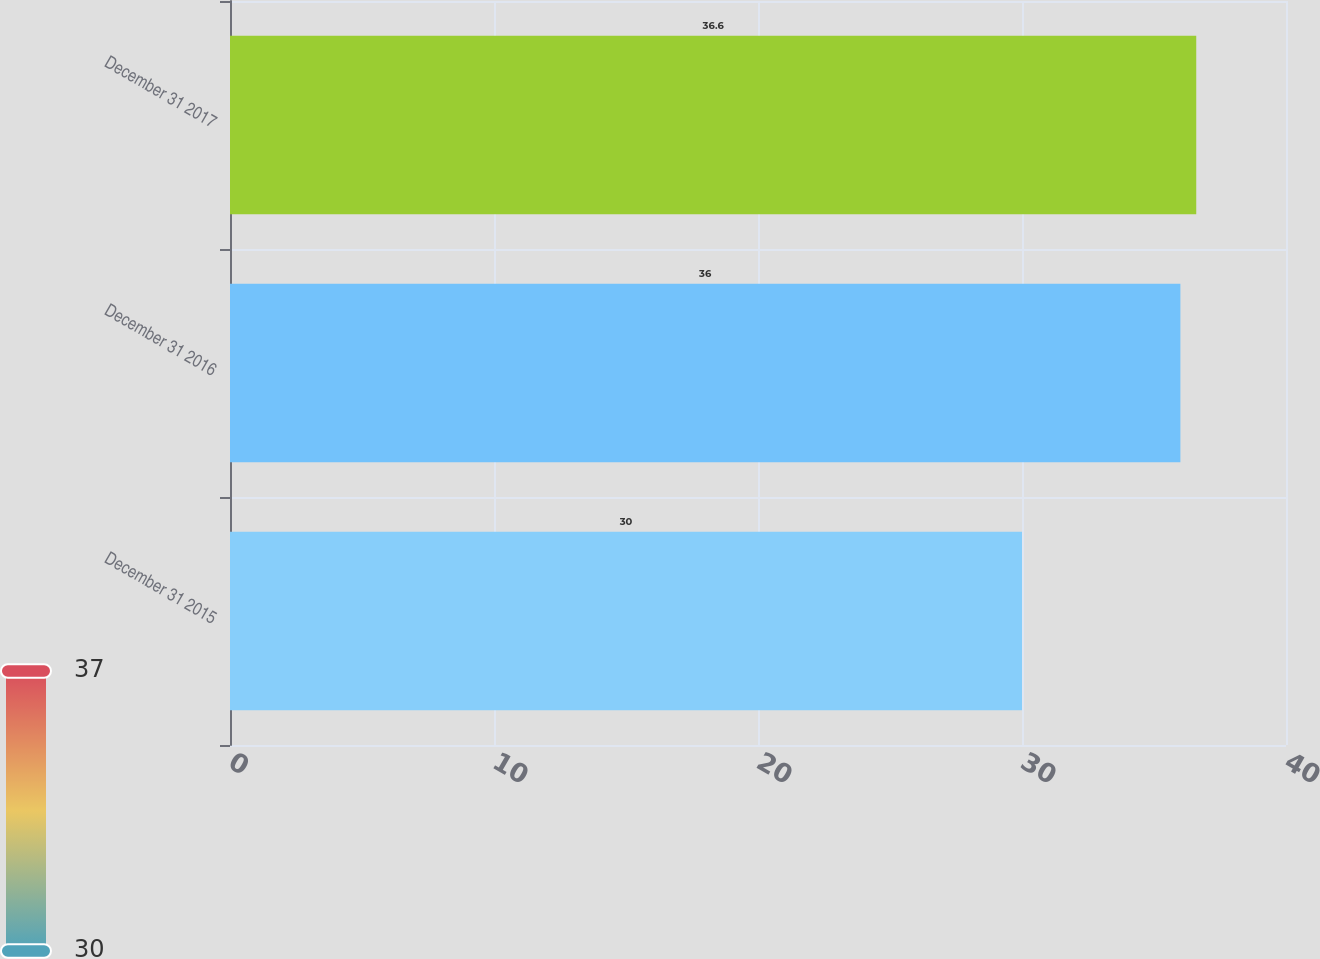Convert chart. <chart><loc_0><loc_0><loc_500><loc_500><bar_chart><fcel>December 31 2015<fcel>December 31 2016<fcel>December 31 2017<nl><fcel>30<fcel>36<fcel>36.6<nl></chart> 